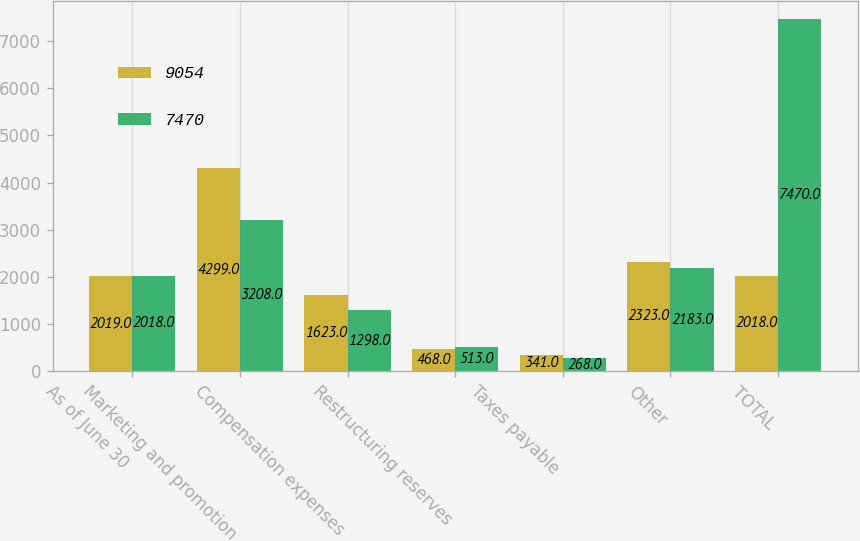Convert chart to OTSL. <chart><loc_0><loc_0><loc_500><loc_500><stacked_bar_chart><ecel><fcel>As of June 30<fcel>Marketing and promotion<fcel>Compensation expenses<fcel>Restructuring reserves<fcel>Taxes payable<fcel>Other<fcel>TOTAL<nl><fcel>9054<fcel>2019<fcel>4299<fcel>1623<fcel>468<fcel>341<fcel>2323<fcel>2018<nl><fcel>7470<fcel>2018<fcel>3208<fcel>1298<fcel>513<fcel>268<fcel>2183<fcel>7470<nl></chart> 